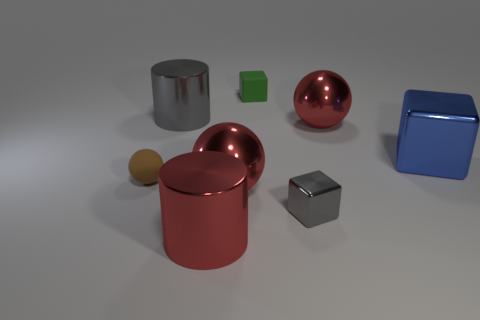Add 1 large balls. How many objects exist? 9 Subtract all balls. How many objects are left? 5 Add 6 large red metallic things. How many large red metallic things are left? 9 Add 6 blue metal balls. How many blue metal balls exist? 6 Subtract 0 purple cylinders. How many objects are left? 8 Subtract all tiny matte balls. Subtract all green rubber things. How many objects are left? 6 